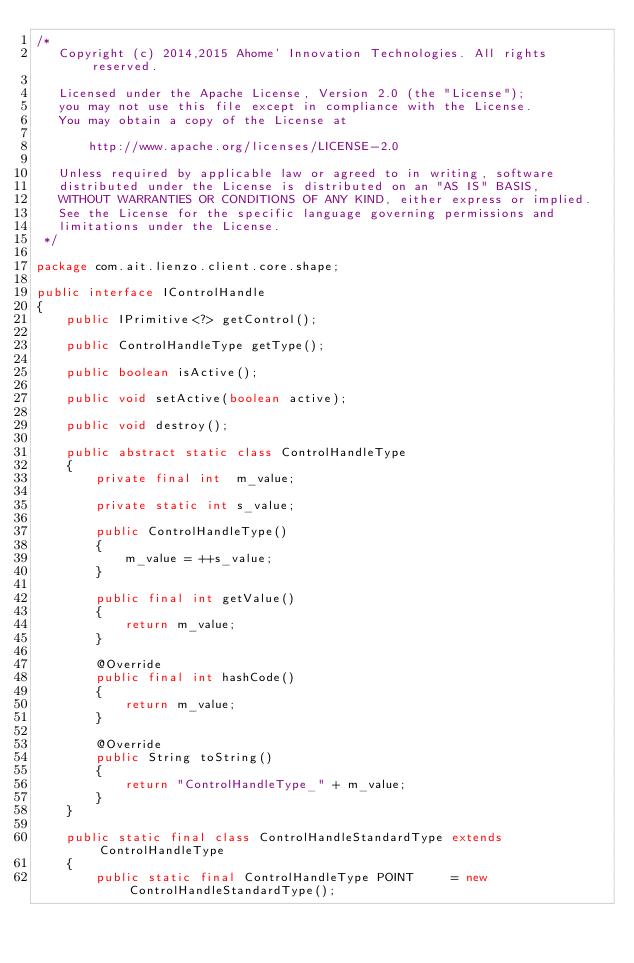<code> <loc_0><loc_0><loc_500><loc_500><_Java_>/*
   Copyright (c) 2014,2015 Ahome' Innovation Technologies. All rights reserved.

   Licensed under the Apache License, Version 2.0 (the "License");
   you may not use this file except in compliance with the License.
   You may obtain a copy of the License at

       http://www.apache.org/licenses/LICENSE-2.0

   Unless required by applicable law or agreed to in writing, software
   distributed under the License is distributed on an "AS IS" BASIS,
   WITHOUT WARRANTIES OR CONDITIONS OF ANY KIND, either express or implied.
   See the License for the specific language governing permissions and
   limitations under the License.
 */

package com.ait.lienzo.client.core.shape;

public interface IControlHandle
{
    public IPrimitive<?> getControl();

    public ControlHandleType getType();

    public boolean isActive();

    public void setActive(boolean active);

    public void destroy();

    public abstract static class ControlHandleType
    {
        private final int  m_value;

        private static int s_value;

        public ControlHandleType()
        {
            m_value = ++s_value;
        }

        public final int getValue()
        {
            return m_value;
        }

        @Override
        public final int hashCode()
        {
            return m_value;
        }

        @Override
        public String toString()
        {
            return "ControlHandleType_" + m_value;
        }
    }

    public static final class ControlHandleStandardType extends ControlHandleType
    {
        public static final ControlHandleType POINT     = new ControlHandleStandardType();
</code> 